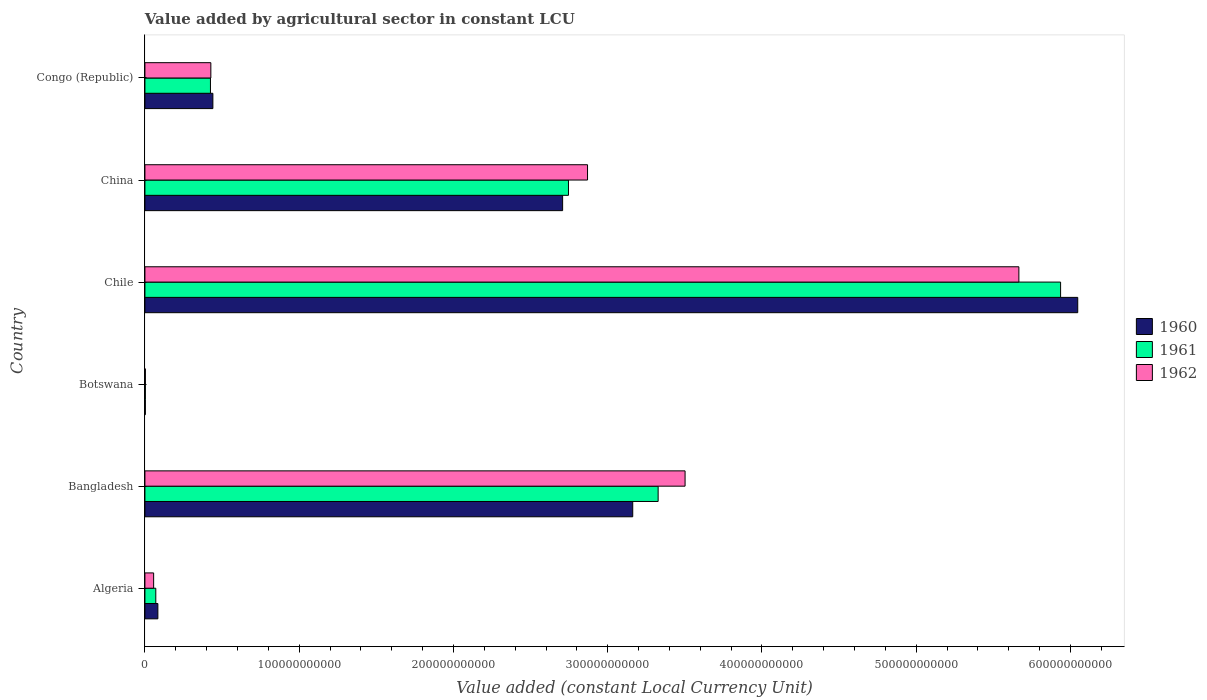How many different coloured bars are there?
Your answer should be very brief. 3. How many bars are there on the 3rd tick from the top?
Provide a succinct answer. 3. How many bars are there on the 6th tick from the bottom?
Offer a terse response. 3. What is the label of the 5th group of bars from the top?
Give a very brief answer. Bangladesh. What is the value added by agricultural sector in 1960 in Botswana?
Offer a very short reply. 2.79e+08. Across all countries, what is the maximum value added by agricultural sector in 1961?
Provide a succinct answer. 5.94e+11. Across all countries, what is the minimum value added by agricultural sector in 1960?
Your answer should be compact. 2.79e+08. In which country was the value added by agricultural sector in 1962 minimum?
Make the answer very short. Botswana. What is the total value added by agricultural sector in 1961 in the graph?
Offer a terse response. 1.25e+12. What is the difference between the value added by agricultural sector in 1961 in Algeria and that in Bangladesh?
Make the answer very short. -3.26e+11. What is the difference between the value added by agricultural sector in 1961 in Algeria and the value added by agricultural sector in 1962 in China?
Give a very brief answer. -2.80e+11. What is the average value added by agricultural sector in 1962 per country?
Provide a short and direct response. 2.09e+11. What is the difference between the value added by agricultural sector in 1962 and value added by agricultural sector in 1961 in Algeria?
Your answer should be compact. -1.40e+09. What is the ratio of the value added by agricultural sector in 1962 in Botswana to that in Congo (Republic)?
Give a very brief answer. 0.01. What is the difference between the highest and the second highest value added by agricultural sector in 1961?
Your answer should be compact. 2.61e+11. What is the difference between the highest and the lowest value added by agricultural sector in 1961?
Offer a terse response. 5.93e+11. In how many countries, is the value added by agricultural sector in 1960 greater than the average value added by agricultural sector in 1960 taken over all countries?
Ensure brevity in your answer.  3. Is the sum of the value added by agricultural sector in 1960 in Bangladesh and Chile greater than the maximum value added by agricultural sector in 1961 across all countries?
Your answer should be very brief. Yes. What does the 1st bar from the top in Botswana represents?
Provide a succinct answer. 1962. Is it the case that in every country, the sum of the value added by agricultural sector in 1960 and value added by agricultural sector in 1961 is greater than the value added by agricultural sector in 1962?
Make the answer very short. Yes. How many bars are there?
Your answer should be very brief. 18. Are all the bars in the graph horizontal?
Ensure brevity in your answer.  Yes. How many countries are there in the graph?
Your answer should be compact. 6. What is the difference between two consecutive major ticks on the X-axis?
Make the answer very short. 1.00e+11. Are the values on the major ticks of X-axis written in scientific E-notation?
Your response must be concise. No. Does the graph contain grids?
Your answer should be compact. No. How are the legend labels stacked?
Your answer should be compact. Vertical. What is the title of the graph?
Provide a short and direct response. Value added by agricultural sector in constant LCU. Does "1995" appear as one of the legend labels in the graph?
Ensure brevity in your answer.  No. What is the label or title of the X-axis?
Give a very brief answer. Value added (constant Local Currency Unit). What is the label or title of the Y-axis?
Your answer should be compact. Country. What is the Value added (constant Local Currency Unit) in 1960 in Algeria?
Your answer should be very brief. 8.40e+09. What is the Value added (constant Local Currency Unit) of 1961 in Algeria?
Make the answer very short. 7.05e+09. What is the Value added (constant Local Currency Unit) in 1962 in Algeria?
Keep it short and to the point. 5.66e+09. What is the Value added (constant Local Currency Unit) in 1960 in Bangladesh?
Offer a very short reply. 3.16e+11. What is the Value added (constant Local Currency Unit) of 1961 in Bangladesh?
Offer a very short reply. 3.33e+11. What is the Value added (constant Local Currency Unit) of 1962 in Bangladesh?
Make the answer very short. 3.50e+11. What is the Value added (constant Local Currency Unit) of 1960 in Botswana?
Offer a terse response. 2.79e+08. What is the Value added (constant Local Currency Unit) of 1961 in Botswana?
Give a very brief answer. 2.86e+08. What is the Value added (constant Local Currency Unit) in 1962 in Botswana?
Your answer should be very brief. 2.96e+08. What is the Value added (constant Local Currency Unit) of 1960 in Chile?
Offer a very short reply. 6.05e+11. What is the Value added (constant Local Currency Unit) of 1961 in Chile?
Provide a short and direct response. 5.94e+11. What is the Value added (constant Local Currency Unit) of 1962 in Chile?
Keep it short and to the point. 5.67e+11. What is the Value added (constant Local Currency Unit) in 1960 in China?
Offer a terse response. 2.71e+11. What is the Value added (constant Local Currency Unit) in 1961 in China?
Your response must be concise. 2.75e+11. What is the Value added (constant Local Currency Unit) of 1962 in China?
Your answer should be very brief. 2.87e+11. What is the Value added (constant Local Currency Unit) in 1960 in Congo (Republic)?
Give a very brief answer. 4.41e+1. What is the Value added (constant Local Currency Unit) of 1961 in Congo (Republic)?
Make the answer very short. 4.25e+1. What is the Value added (constant Local Currency Unit) in 1962 in Congo (Republic)?
Keep it short and to the point. 4.27e+1. Across all countries, what is the maximum Value added (constant Local Currency Unit) of 1960?
Make the answer very short. 6.05e+11. Across all countries, what is the maximum Value added (constant Local Currency Unit) of 1961?
Provide a short and direct response. 5.94e+11. Across all countries, what is the maximum Value added (constant Local Currency Unit) of 1962?
Make the answer very short. 5.67e+11. Across all countries, what is the minimum Value added (constant Local Currency Unit) of 1960?
Give a very brief answer. 2.79e+08. Across all countries, what is the minimum Value added (constant Local Currency Unit) of 1961?
Give a very brief answer. 2.86e+08. Across all countries, what is the minimum Value added (constant Local Currency Unit) in 1962?
Ensure brevity in your answer.  2.96e+08. What is the total Value added (constant Local Currency Unit) of 1960 in the graph?
Provide a succinct answer. 1.24e+12. What is the total Value added (constant Local Currency Unit) of 1961 in the graph?
Offer a terse response. 1.25e+12. What is the total Value added (constant Local Currency Unit) in 1962 in the graph?
Give a very brief answer. 1.25e+12. What is the difference between the Value added (constant Local Currency Unit) in 1960 in Algeria and that in Bangladesh?
Offer a very short reply. -3.08e+11. What is the difference between the Value added (constant Local Currency Unit) in 1961 in Algeria and that in Bangladesh?
Ensure brevity in your answer.  -3.26e+11. What is the difference between the Value added (constant Local Currency Unit) of 1962 in Algeria and that in Bangladesh?
Keep it short and to the point. -3.44e+11. What is the difference between the Value added (constant Local Currency Unit) of 1960 in Algeria and that in Botswana?
Offer a very short reply. 8.12e+09. What is the difference between the Value added (constant Local Currency Unit) of 1961 in Algeria and that in Botswana?
Provide a short and direct response. 6.77e+09. What is the difference between the Value added (constant Local Currency Unit) of 1962 in Algeria and that in Botswana?
Provide a succinct answer. 5.36e+09. What is the difference between the Value added (constant Local Currency Unit) of 1960 in Algeria and that in Chile?
Provide a short and direct response. -5.96e+11. What is the difference between the Value added (constant Local Currency Unit) of 1961 in Algeria and that in Chile?
Give a very brief answer. -5.87e+11. What is the difference between the Value added (constant Local Currency Unit) in 1962 in Algeria and that in Chile?
Make the answer very short. -5.61e+11. What is the difference between the Value added (constant Local Currency Unit) in 1960 in Algeria and that in China?
Offer a very short reply. -2.62e+11. What is the difference between the Value added (constant Local Currency Unit) of 1961 in Algeria and that in China?
Provide a short and direct response. -2.68e+11. What is the difference between the Value added (constant Local Currency Unit) of 1962 in Algeria and that in China?
Offer a very short reply. -2.81e+11. What is the difference between the Value added (constant Local Currency Unit) in 1960 in Algeria and that in Congo (Republic)?
Provide a succinct answer. -3.57e+1. What is the difference between the Value added (constant Local Currency Unit) of 1961 in Algeria and that in Congo (Republic)?
Provide a short and direct response. -3.54e+1. What is the difference between the Value added (constant Local Currency Unit) in 1962 in Algeria and that in Congo (Republic)?
Offer a very short reply. -3.71e+1. What is the difference between the Value added (constant Local Currency Unit) in 1960 in Bangladesh and that in Botswana?
Provide a succinct answer. 3.16e+11. What is the difference between the Value added (constant Local Currency Unit) of 1961 in Bangladesh and that in Botswana?
Provide a short and direct response. 3.32e+11. What is the difference between the Value added (constant Local Currency Unit) in 1962 in Bangladesh and that in Botswana?
Your answer should be very brief. 3.50e+11. What is the difference between the Value added (constant Local Currency Unit) of 1960 in Bangladesh and that in Chile?
Your answer should be very brief. -2.88e+11. What is the difference between the Value added (constant Local Currency Unit) of 1961 in Bangladesh and that in Chile?
Your answer should be compact. -2.61e+11. What is the difference between the Value added (constant Local Currency Unit) in 1962 in Bangladesh and that in Chile?
Make the answer very short. -2.16e+11. What is the difference between the Value added (constant Local Currency Unit) of 1960 in Bangladesh and that in China?
Keep it short and to the point. 4.54e+1. What is the difference between the Value added (constant Local Currency Unit) in 1961 in Bangladesh and that in China?
Keep it short and to the point. 5.81e+1. What is the difference between the Value added (constant Local Currency Unit) in 1962 in Bangladesh and that in China?
Offer a very short reply. 6.32e+1. What is the difference between the Value added (constant Local Currency Unit) in 1960 in Bangladesh and that in Congo (Republic)?
Provide a short and direct response. 2.72e+11. What is the difference between the Value added (constant Local Currency Unit) of 1961 in Bangladesh and that in Congo (Republic)?
Make the answer very short. 2.90e+11. What is the difference between the Value added (constant Local Currency Unit) in 1962 in Bangladesh and that in Congo (Republic)?
Keep it short and to the point. 3.07e+11. What is the difference between the Value added (constant Local Currency Unit) of 1960 in Botswana and that in Chile?
Offer a very short reply. -6.04e+11. What is the difference between the Value added (constant Local Currency Unit) in 1961 in Botswana and that in Chile?
Ensure brevity in your answer.  -5.93e+11. What is the difference between the Value added (constant Local Currency Unit) in 1962 in Botswana and that in Chile?
Ensure brevity in your answer.  -5.66e+11. What is the difference between the Value added (constant Local Currency Unit) of 1960 in Botswana and that in China?
Offer a very short reply. -2.70e+11. What is the difference between the Value added (constant Local Currency Unit) in 1961 in Botswana and that in China?
Offer a terse response. -2.74e+11. What is the difference between the Value added (constant Local Currency Unit) in 1962 in Botswana and that in China?
Provide a short and direct response. -2.87e+11. What is the difference between the Value added (constant Local Currency Unit) of 1960 in Botswana and that in Congo (Republic)?
Make the answer very short. -4.38e+1. What is the difference between the Value added (constant Local Currency Unit) in 1961 in Botswana and that in Congo (Republic)?
Ensure brevity in your answer.  -4.22e+1. What is the difference between the Value added (constant Local Currency Unit) in 1962 in Botswana and that in Congo (Republic)?
Give a very brief answer. -4.24e+1. What is the difference between the Value added (constant Local Currency Unit) in 1960 in Chile and that in China?
Offer a very short reply. 3.34e+11. What is the difference between the Value added (constant Local Currency Unit) of 1961 in Chile and that in China?
Keep it short and to the point. 3.19e+11. What is the difference between the Value added (constant Local Currency Unit) in 1962 in Chile and that in China?
Make the answer very short. 2.80e+11. What is the difference between the Value added (constant Local Currency Unit) of 1960 in Chile and that in Congo (Republic)?
Your response must be concise. 5.61e+11. What is the difference between the Value added (constant Local Currency Unit) of 1961 in Chile and that in Congo (Republic)?
Offer a very short reply. 5.51e+11. What is the difference between the Value added (constant Local Currency Unit) of 1962 in Chile and that in Congo (Republic)?
Provide a short and direct response. 5.24e+11. What is the difference between the Value added (constant Local Currency Unit) in 1960 in China and that in Congo (Republic)?
Provide a short and direct response. 2.27e+11. What is the difference between the Value added (constant Local Currency Unit) of 1961 in China and that in Congo (Republic)?
Offer a terse response. 2.32e+11. What is the difference between the Value added (constant Local Currency Unit) of 1962 in China and that in Congo (Republic)?
Your answer should be very brief. 2.44e+11. What is the difference between the Value added (constant Local Currency Unit) of 1960 in Algeria and the Value added (constant Local Currency Unit) of 1961 in Bangladesh?
Your answer should be compact. -3.24e+11. What is the difference between the Value added (constant Local Currency Unit) of 1960 in Algeria and the Value added (constant Local Currency Unit) of 1962 in Bangladesh?
Your response must be concise. -3.42e+11. What is the difference between the Value added (constant Local Currency Unit) of 1961 in Algeria and the Value added (constant Local Currency Unit) of 1962 in Bangladesh?
Your answer should be compact. -3.43e+11. What is the difference between the Value added (constant Local Currency Unit) in 1960 in Algeria and the Value added (constant Local Currency Unit) in 1961 in Botswana?
Ensure brevity in your answer.  8.11e+09. What is the difference between the Value added (constant Local Currency Unit) of 1960 in Algeria and the Value added (constant Local Currency Unit) of 1962 in Botswana?
Provide a succinct answer. 8.10e+09. What is the difference between the Value added (constant Local Currency Unit) in 1961 in Algeria and the Value added (constant Local Currency Unit) in 1962 in Botswana?
Offer a very short reply. 6.76e+09. What is the difference between the Value added (constant Local Currency Unit) in 1960 in Algeria and the Value added (constant Local Currency Unit) in 1961 in Chile?
Keep it short and to the point. -5.85e+11. What is the difference between the Value added (constant Local Currency Unit) in 1960 in Algeria and the Value added (constant Local Currency Unit) in 1962 in Chile?
Ensure brevity in your answer.  -5.58e+11. What is the difference between the Value added (constant Local Currency Unit) of 1961 in Algeria and the Value added (constant Local Currency Unit) of 1962 in Chile?
Keep it short and to the point. -5.59e+11. What is the difference between the Value added (constant Local Currency Unit) in 1960 in Algeria and the Value added (constant Local Currency Unit) in 1961 in China?
Your answer should be very brief. -2.66e+11. What is the difference between the Value added (constant Local Currency Unit) in 1960 in Algeria and the Value added (constant Local Currency Unit) in 1962 in China?
Your answer should be very brief. -2.79e+11. What is the difference between the Value added (constant Local Currency Unit) of 1961 in Algeria and the Value added (constant Local Currency Unit) of 1962 in China?
Your answer should be compact. -2.80e+11. What is the difference between the Value added (constant Local Currency Unit) of 1960 in Algeria and the Value added (constant Local Currency Unit) of 1961 in Congo (Republic)?
Provide a succinct answer. -3.41e+1. What is the difference between the Value added (constant Local Currency Unit) of 1960 in Algeria and the Value added (constant Local Currency Unit) of 1962 in Congo (Republic)?
Your answer should be very brief. -3.43e+1. What is the difference between the Value added (constant Local Currency Unit) in 1961 in Algeria and the Value added (constant Local Currency Unit) in 1962 in Congo (Republic)?
Offer a terse response. -3.57e+1. What is the difference between the Value added (constant Local Currency Unit) of 1960 in Bangladesh and the Value added (constant Local Currency Unit) of 1961 in Botswana?
Offer a terse response. 3.16e+11. What is the difference between the Value added (constant Local Currency Unit) of 1960 in Bangladesh and the Value added (constant Local Currency Unit) of 1962 in Botswana?
Offer a very short reply. 3.16e+11. What is the difference between the Value added (constant Local Currency Unit) of 1961 in Bangladesh and the Value added (constant Local Currency Unit) of 1962 in Botswana?
Your response must be concise. 3.32e+11. What is the difference between the Value added (constant Local Currency Unit) in 1960 in Bangladesh and the Value added (constant Local Currency Unit) in 1961 in Chile?
Make the answer very short. -2.77e+11. What is the difference between the Value added (constant Local Currency Unit) in 1960 in Bangladesh and the Value added (constant Local Currency Unit) in 1962 in Chile?
Offer a very short reply. -2.50e+11. What is the difference between the Value added (constant Local Currency Unit) in 1961 in Bangladesh and the Value added (constant Local Currency Unit) in 1962 in Chile?
Offer a very short reply. -2.34e+11. What is the difference between the Value added (constant Local Currency Unit) in 1960 in Bangladesh and the Value added (constant Local Currency Unit) in 1961 in China?
Provide a succinct answer. 4.17e+1. What is the difference between the Value added (constant Local Currency Unit) of 1960 in Bangladesh and the Value added (constant Local Currency Unit) of 1962 in China?
Give a very brief answer. 2.93e+1. What is the difference between the Value added (constant Local Currency Unit) of 1961 in Bangladesh and the Value added (constant Local Currency Unit) of 1962 in China?
Offer a very short reply. 4.58e+1. What is the difference between the Value added (constant Local Currency Unit) in 1960 in Bangladesh and the Value added (constant Local Currency Unit) in 1961 in Congo (Republic)?
Offer a very short reply. 2.74e+11. What is the difference between the Value added (constant Local Currency Unit) in 1960 in Bangladesh and the Value added (constant Local Currency Unit) in 1962 in Congo (Republic)?
Offer a terse response. 2.73e+11. What is the difference between the Value added (constant Local Currency Unit) of 1961 in Bangladesh and the Value added (constant Local Currency Unit) of 1962 in Congo (Republic)?
Offer a terse response. 2.90e+11. What is the difference between the Value added (constant Local Currency Unit) of 1960 in Botswana and the Value added (constant Local Currency Unit) of 1961 in Chile?
Provide a succinct answer. -5.93e+11. What is the difference between the Value added (constant Local Currency Unit) in 1960 in Botswana and the Value added (constant Local Currency Unit) in 1962 in Chile?
Make the answer very short. -5.66e+11. What is the difference between the Value added (constant Local Currency Unit) of 1961 in Botswana and the Value added (constant Local Currency Unit) of 1962 in Chile?
Offer a very short reply. -5.66e+11. What is the difference between the Value added (constant Local Currency Unit) in 1960 in Botswana and the Value added (constant Local Currency Unit) in 1961 in China?
Your answer should be very brief. -2.74e+11. What is the difference between the Value added (constant Local Currency Unit) in 1960 in Botswana and the Value added (constant Local Currency Unit) in 1962 in China?
Ensure brevity in your answer.  -2.87e+11. What is the difference between the Value added (constant Local Currency Unit) of 1961 in Botswana and the Value added (constant Local Currency Unit) of 1962 in China?
Your answer should be compact. -2.87e+11. What is the difference between the Value added (constant Local Currency Unit) of 1960 in Botswana and the Value added (constant Local Currency Unit) of 1961 in Congo (Republic)?
Your answer should be very brief. -4.22e+1. What is the difference between the Value added (constant Local Currency Unit) in 1960 in Botswana and the Value added (constant Local Currency Unit) in 1962 in Congo (Republic)?
Give a very brief answer. -4.25e+1. What is the difference between the Value added (constant Local Currency Unit) in 1961 in Botswana and the Value added (constant Local Currency Unit) in 1962 in Congo (Republic)?
Your response must be concise. -4.25e+1. What is the difference between the Value added (constant Local Currency Unit) of 1960 in Chile and the Value added (constant Local Currency Unit) of 1961 in China?
Make the answer very short. 3.30e+11. What is the difference between the Value added (constant Local Currency Unit) of 1960 in Chile and the Value added (constant Local Currency Unit) of 1962 in China?
Ensure brevity in your answer.  3.18e+11. What is the difference between the Value added (constant Local Currency Unit) of 1961 in Chile and the Value added (constant Local Currency Unit) of 1962 in China?
Keep it short and to the point. 3.07e+11. What is the difference between the Value added (constant Local Currency Unit) in 1960 in Chile and the Value added (constant Local Currency Unit) in 1961 in Congo (Republic)?
Ensure brevity in your answer.  5.62e+11. What is the difference between the Value added (constant Local Currency Unit) of 1960 in Chile and the Value added (constant Local Currency Unit) of 1962 in Congo (Republic)?
Your answer should be very brief. 5.62e+11. What is the difference between the Value added (constant Local Currency Unit) in 1961 in Chile and the Value added (constant Local Currency Unit) in 1962 in Congo (Republic)?
Your answer should be very brief. 5.51e+11. What is the difference between the Value added (constant Local Currency Unit) of 1960 in China and the Value added (constant Local Currency Unit) of 1961 in Congo (Republic)?
Make the answer very short. 2.28e+11. What is the difference between the Value added (constant Local Currency Unit) of 1960 in China and the Value added (constant Local Currency Unit) of 1962 in Congo (Republic)?
Ensure brevity in your answer.  2.28e+11. What is the difference between the Value added (constant Local Currency Unit) in 1961 in China and the Value added (constant Local Currency Unit) in 1962 in Congo (Republic)?
Your answer should be very brief. 2.32e+11. What is the average Value added (constant Local Currency Unit) of 1960 per country?
Keep it short and to the point. 2.07e+11. What is the average Value added (constant Local Currency Unit) of 1961 per country?
Keep it short and to the point. 2.08e+11. What is the average Value added (constant Local Currency Unit) of 1962 per country?
Provide a short and direct response. 2.09e+11. What is the difference between the Value added (constant Local Currency Unit) of 1960 and Value added (constant Local Currency Unit) of 1961 in Algeria?
Make the answer very short. 1.35e+09. What is the difference between the Value added (constant Local Currency Unit) in 1960 and Value added (constant Local Currency Unit) in 1962 in Algeria?
Your response must be concise. 2.74e+09. What is the difference between the Value added (constant Local Currency Unit) in 1961 and Value added (constant Local Currency Unit) in 1962 in Algeria?
Give a very brief answer. 1.40e+09. What is the difference between the Value added (constant Local Currency Unit) in 1960 and Value added (constant Local Currency Unit) in 1961 in Bangladesh?
Offer a terse response. -1.65e+1. What is the difference between the Value added (constant Local Currency Unit) in 1960 and Value added (constant Local Currency Unit) in 1962 in Bangladesh?
Give a very brief answer. -3.39e+1. What is the difference between the Value added (constant Local Currency Unit) in 1961 and Value added (constant Local Currency Unit) in 1962 in Bangladesh?
Keep it short and to the point. -1.75e+1. What is the difference between the Value added (constant Local Currency Unit) of 1960 and Value added (constant Local Currency Unit) of 1961 in Botswana?
Give a very brief answer. -6.88e+06. What is the difference between the Value added (constant Local Currency Unit) in 1960 and Value added (constant Local Currency Unit) in 1962 in Botswana?
Give a very brief answer. -1.72e+07. What is the difference between the Value added (constant Local Currency Unit) in 1961 and Value added (constant Local Currency Unit) in 1962 in Botswana?
Provide a succinct answer. -1.03e+07. What is the difference between the Value added (constant Local Currency Unit) in 1960 and Value added (constant Local Currency Unit) in 1961 in Chile?
Offer a terse response. 1.11e+1. What is the difference between the Value added (constant Local Currency Unit) of 1960 and Value added (constant Local Currency Unit) of 1962 in Chile?
Offer a very short reply. 3.82e+1. What is the difference between the Value added (constant Local Currency Unit) of 1961 and Value added (constant Local Currency Unit) of 1962 in Chile?
Keep it short and to the point. 2.70e+1. What is the difference between the Value added (constant Local Currency Unit) of 1960 and Value added (constant Local Currency Unit) of 1961 in China?
Make the answer very short. -3.79e+09. What is the difference between the Value added (constant Local Currency Unit) in 1960 and Value added (constant Local Currency Unit) in 1962 in China?
Provide a short and direct response. -1.61e+1. What is the difference between the Value added (constant Local Currency Unit) of 1961 and Value added (constant Local Currency Unit) of 1962 in China?
Give a very brief answer. -1.24e+1. What is the difference between the Value added (constant Local Currency Unit) in 1960 and Value added (constant Local Currency Unit) in 1961 in Congo (Republic)?
Provide a short and direct response. 1.57e+09. What is the difference between the Value added (constant Local Currency Unit) of 1960 and Value added (constant Local Currency Unit) of 1962 in Congo (Republic)?
Keep it short and to the point. 1.32e+09. What is the difference between the Value added (constant Local Currency Unit) in 1961 and Value added (constant Local Currency Unit) in 1962 in Congo (Republic)?
Your response must be concise. -2.56e+08. What is the ratio of the Value added (constant Local Currency Unit) in 1960 in Algeria to that in Bangladesh?
Offer a very short reply. 0.03. What is the ratio of the Value added (constant Local Currency Unit) in 1961 in Algeria to that in Bangladesh?
Provide a short and direct response. 0.02. What is the ratio of the Value added (constant Local Currency Unit) of 1962 in Algeria to that in Bangladesh?
Provide a short and direct response. 0.02. What is the ratio of the Value added (constant Local Currency Unit) of 1960 in Algeria to that in Botswana?
Make the answer very short. 30.08. What is the ratio of the Value added (constant Local Currency Unit) of 1961 in Algeria to that in Botswana?
Provide a succinct answer. 24.65. What is the ratio of the Value added (constant Local Currency Unit) in 1962 in Algeria to that in Botswana?
Offer a terse response. 19.09. What is the ratio of the Value added (constant Local Currency Unit) in 1960 in Algeria to that in Chile?
Your response must be concise. 0.01. What is the ratio of the Value added (constant Local Currency Unit) in 1961 in Algeria to that in Chile?
Ensure brevity in your answer.  0.01. What is the ratio of the Value added (constant Local Currency Unit) in 1960 in Algeria to that in China?
Ensure brevity in your answer.  0.03. What is the ratio of the Value added (constant Local Currency Unit) in 1961 in Algeria to that in China?
Give a very brief answer. 0.03. What is the ratio of the Value added (constant Local Currency Unit) of 1962 in Algeria to that in China?
Provide a short and direct response. 0.02. What is the ratio of the Value added (constant Local Currency Unit) in 1960 in Algeria to that in Congo (Republic)?
Keep it short and to the point. 0.19. What is the ratio of the Value added (constant Local Currency Unit) in 1961 in Algeria to that in Congo (Republic)?
Offer a terse response. 0.17. What is the ratio of the Value added (constant Local Currency Unit) in 1962 in Algeria to that in Congo (Republic)?
Ensure brevity in your answer.  0.13. What is the ratio of the Value added (constant Local Currency Unit) in 1960 in Bangladesh to that in Botswana?
Make the answer very short. 1132.8. What is the ratio of the Value added (constant Local Currency Unit) in 1961 in Bangladesh to that in Botswana?
Provide a short and direct response. 1163.15. What is the ratio of the Value added (constant Local Currency Unit) of 1962 in Bangladesh to that in Botswana?
Make the answer very short. 1181.56. What is the ratio of the Value added (constant Local Currency Unit) of 1960 in Bangladesh to that in Chile?
Offer a terse response. 0.52. What is the ratio of the Value added (constant Local Currency Unit) of 1961 in Bangladesh to that in Chile?
Your answer should be very brief. 0.56. What is the ratio of the Value added (constant Local Currency Unit) in 1962 in Bangladesh to that in Chile?
Give a very brief answer. 0.62. What is the ratio of the Value added (constant Local Currency Unit) of 1960 in Bangladesh to that in China?
Your answer should be compact. 1.17. What is the ratio of the Value added (constant Local Currency Unit) in 1961 in Bangladesh to that in China?
Ensure brevity in your answer.  1.21. What is the ratio of the Value added (constant Local Currency Unit) in 1962 in Bangladesh to that in China?
Ensure brevity in your answer.  1.22. What is the ratio of the Value added (constant Local Currency Unit) in 1960 in Bangladesh to that in Congo (Republic)?
Give a very brief answer. 7.18. What is the ratio of the Value added (constant Local Currency Unit) in 1961 in Bangladesh to that in Congo (Republic)?
Offer a very short reply. 7.83. What is the ratio of the Value added (constant Local Currency Unit) of 1962 in Bangladesh to that in Congo (Republic)?
Keep it short and to the point. 8.19. What is the ratio of the Value added (constant Local Currency Unit) of 1961 in Botswana to that in Chile?
Your answer should be very brief. 0. What is the ratio of the Value added (constant Local Currency Unit) in 1961 in Botswana to that in China?
Make the answer very short. 0. What is the ratio of the Value added (constant Local Currency Unit) of 1962 in Botswana to that in China?
Your answer should be very brief. 0. What is the ratio of the Value added (constant Local Currency Unit) of 1960 in Botswana to that in Congo (Republic)?
Offer a terse response. 0.01. What is the ratio of the Value added (constant Local Currency Unit) in 1961 in Botswana to that in Congo (Republic)?
Give a very brief answer. 0.01. What is the ratio of the Value added (constant Local Currency Unit) in 1962 in Botswana to that in Congo (Republic)?
Your answer should be very brief. 0.01. What is the ratio of the Value added (constant Local Currency Unit) of 1960 in Chile to that in China?
Offer a terse response. 2.23. What is the ratio of the Value added (constant Local Currency Unit) in 1961 in Chile to that in China?
Keep it short and to the point. 2.16. What is the ratio of the Value added (constant Local Currency Unit) of 1962 in Chile to that in China?
Give a very brief answer. 1.97. What is the ratio of the Value added (constant Local Currency Unit) in 1960 in Chile to that in Congo (Republic)?
Your answer should be compact. 13.73. What is the ratio of the Value added (constant Local Currency Unit) in 1961 in Chile to that in Congo (Republic)?
Ensure brevity in your answer.  13.97. What is the ratio of the Value added (constant Local Currency Unit) of 1962 in Chile to that in Congo (Republic)?
Your answer should be very brief. 13.26. What is the ratio of the Value added (constant Local Currency Unit) of 1960 in China to that in Congo (Republic)?
Offer a very short reply. 6.15. What is the ratio of the Value added (constant Local Currency Unit) of 1961 in China to that in Congo (Republic)?
Offer a very short reply. 6.46. What is the ratio of the Value added (constant Local Currency Unit) of 1962 in China to that in Congo (Republic)?
Your answer should be very brief. 6.71. What is the difference between the highest and the second highest Value added (constant Local Currency Unit) of 1960?
Your answer should be compact. 2.88e+11. What is the difference between the highest and the second highest Value added (constant Local Currency Unit) in 1961?
Provide a succinct answer. 2.61e+11. What is the difference between the highest and the second highest Value added (constant Local Currency Unit) of 1962?
Keep it short and to the point. 2.16e+11. What is the difference between the highest and the lowest Value added (constant Local Currency Unit) of 1960?
Your answer should be very brief. 6.04e+11. What is the difference between the highest and the lowest Value added (constant Local Currency Unit) in 1961?
Offer a very short reply. 5.93e+11. What is the difference between the highest and the lowest Value added (constant Local Currency Unit) in 1962?
Ensure brevity in your answer.  5.66e+11. 